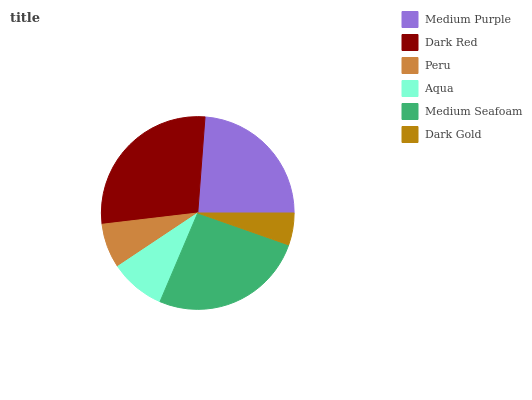Is Dark Gold the minimum?
Answer yes or no. Yes. Is Dark Red the maximum?
Answer yes or no. Yes. Is Peru the minimum?
Answer yes or no. No. Is Peru the maximum?
Answer yes or no. No. Is Dark Red greater than Peru?
Answer yes or no. Yes. Is Peru less than Dark Red?
Answer yes or no. Yes. Is Peru greater than Dark Red?
Answer yes or no. No. Is Dark Red less than Peru?
Answer yes or no. No. Is Medium Purple the high median?
Answer yes or no. Yes. Is Aqua the low median?
Answer yes or no. Yes. Is Dark Gold the high median?
Answer yes or no. No. Is Medium Seafoam the low median?
Answer yes or no. No. 